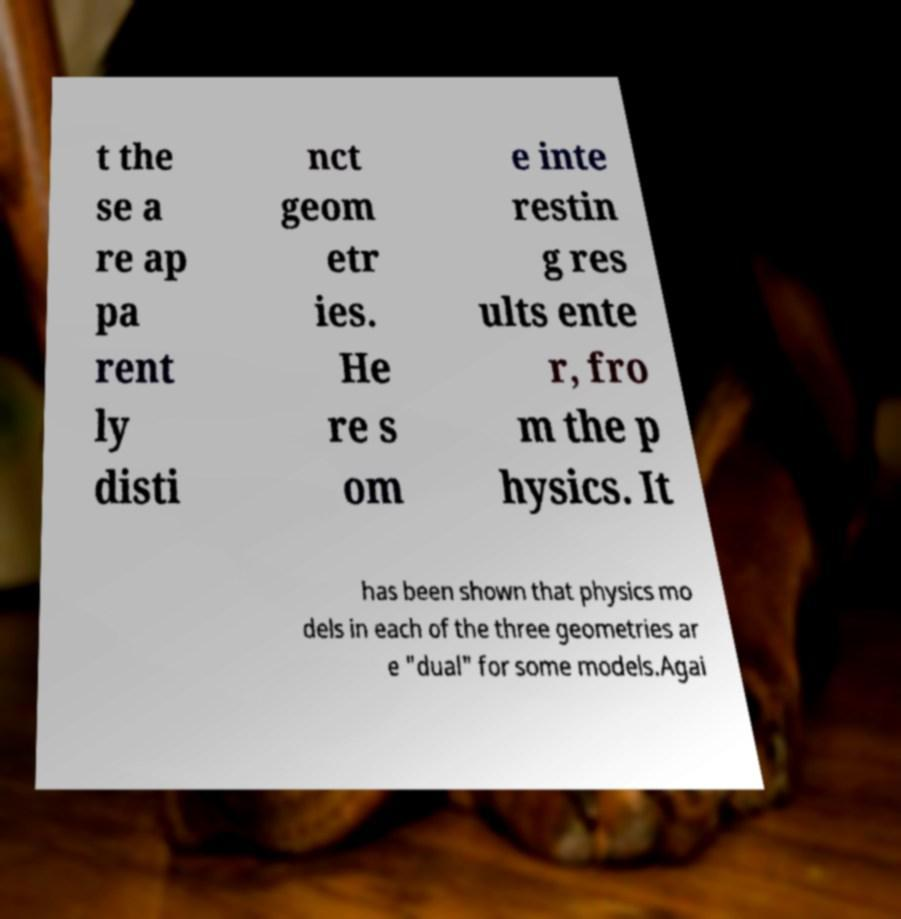What messages or text are displayed in this image? I need them in a readable, typed format. t the se a re ap pa rent ly disti nct geom etr ies. He re s om e inte restin g res ults ente r, fro m the p hysics. It has been shown that physics mo dels in each of the three geometries ar e "dual" for some models.Agai 